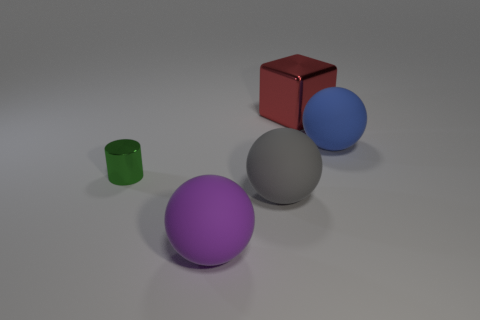What number of big balls are to the right of the large red metallic thing and in front of the large blue object?
Offer a very short reply. 0. How many objects are big purple objects or objects that are right of the large purple rubber sphere?
Give a very brief answer. 4. Is the number of big blue matte spheres greater than the number of tiny brown shiny spheres?
Ensure brevity in your answer.  Yes. There is a metallic object that is on the right side of the big purple matte object; what is its shape?
Provide a short and direct response. Cube. How many other red shiny objects have the same shape as the red metallic object?
Offer a very short reply. 0. What size is the metal object that is left of the big sphere in front of the gray ball?
Your answer should be very brief. Small. What number of purple things are small things or big rubber spheres?
Your answer should be compact. 1. Is the number of tiny metallic things that are right of the purple matte ball less than the number of matte things to the left of the shiny block?
Your response must be concise. Yes. There is a metal cube; is it the same size as the metal object that is in front of the blue matte thing?
Your response must be concise. No. What number of blocks are the same size as the red metal object?
Offer a terse response. 0. 